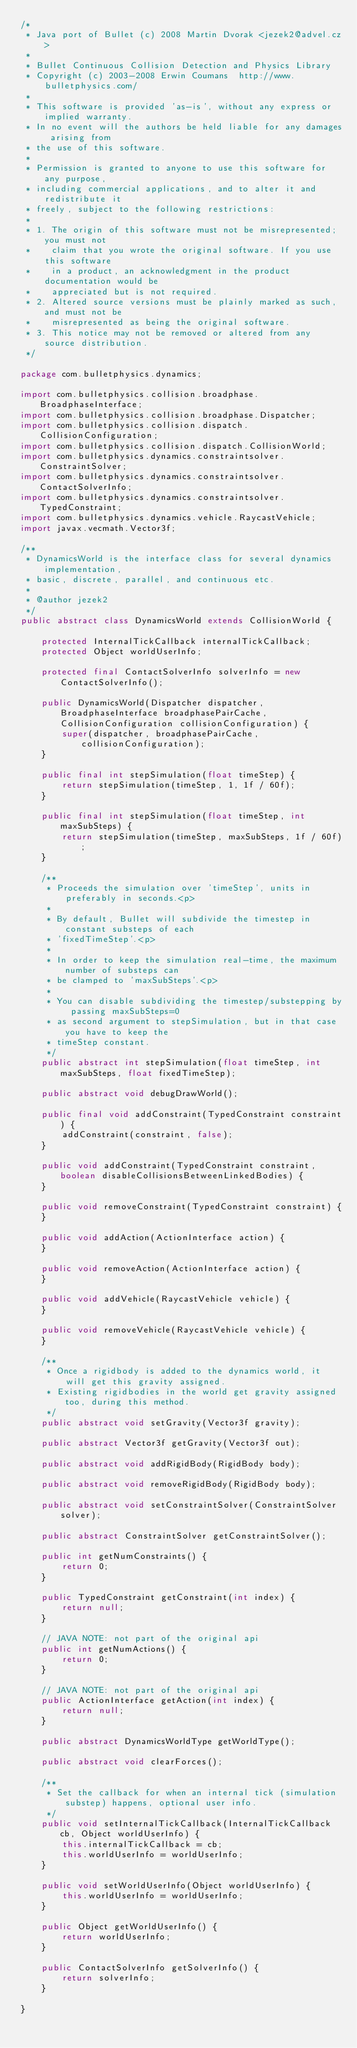Convert code to text. <code><loc_0><loc_0><loc_500><loc_500><_Java_>/*
 * Java port of Bullet (c) 2008 Martin Dvorak <jezek2@advel.cz>
 *
 * Bullet Continuous Collision Detection and Physics Library
 * Copyright (c) 2003-2008 Erwin Coumans  http://www.bulletphysics.com/
 *
 * This software is provided 'as-is', without any express or implied warranty.
 * In no event will the authors be held liable for any damages arising from
 * the use of this software.
 * 
 * Permission is granted to anyone to use this software for any purpose, 
 * including commercial applications, and to alter it and redistribute it
 * freely, subject to the following restrictions:
 * 
 * 1. The origin of this software must not be misrepresented; you must not
 *    claim that you wrote the original software. If you use this software
 *    in a product, an acknowledgment in the product documentation would be
 *    appreciated but is not required.
 * 2. Altered source versions must be plainly marked as such, and must not be
 *    misrepresented as being the original software.
 * 3. This notice may not be removed or altered from any source distribution.
 */

package com.bulletphysics.dynamics;

import com.bulletphysics.collision.broadphase.BroadphaseInterface;
import com.bulletphysics.collision.broadphase.Dispatcher;
import com.bulletphysics.collision.dispatch.CollisionConfiguration;
import com.bulletphysics.collision.dispatch.CollisionWorld;
import com.bulletphysics.dynamics.constraintsolver.ConstraintSolver;
import com.bulletphysics.dynamics.constraintsolver.ContactSolverInfo;
import com.bulletphysics.dynamics.constraintsolver.TypedConstraint;
import com.bulletphysics.dynamics.vehicle.RaycastVehicle;
import javax.vecmath.Vector3f;

/**
 * DynamicsWorld is the interface class for several dynamics implementation,
 * basic, discrete, parallel, and continuous etc.
 * 
 * @author jezek2
 */
public abstract class DynamicsWorld extends CollisionWorld {

	protected InternalTickCallback internalTickCallback;
	protected Object worldUserInfo;
	
	protected final ContactSolverInfo solverInfo = new ContactSolverInfo();
	
	public DynamicsWorld(Dispatcher dispatcher, BroadphaseInterface broadphasePairCache, CollisionConfiguration collisionConfiguration) {
		super(dispatcher, broadphasePairCache, collisionConfiguration);
	}

	public final int stepSimulation(float timeStep) {
		return stepSimulation(timeStep, 1, 1f / 60f);
	}

	public final int stepSimulation(float timeStep, int maxSubSteps) {
		return stepSimulation(timeStep, maxSubSteps, 1f / 60f);
	}

	/**
	 * Proceeds the simulation over 'timeStep', units in preferably in seconds.<p>
	 *
	 * By default, Bullet will subdivide the timestep in constant substeps of each
	 * 'fixedTimeStep'.<p>
	 *
	 * In order to keep the simulation real-time, the maximum number of substeps can
	 * be clamped to 'maxSubSteps'.<p>
	 * 
	 * You can disable subdividing the timestep/substepping by passing maxSubSteps=0
	 * as second argument to stepSimulation, but in that case you have to keep the
	 * timeStep constant.
	 */
	public abstract int stepSimulation(float timeStep, int maxSubSteps, float fixedTimeStep);

	public abstract void debugDrawWorld();

	public final void addConstraint(TypedConstraint constraint) {
		addConstraint(constraint, false);
	}
	
	public void addConstraint(TypedConstraint constraint, boolean disableCollisionsBetweenLinkedBodies) {
	}

	public void removeConstraint(TypedConstraint constraint) {
	}

	public void addAction(ActionInterface action) {
	}

	public void removeAction(ActionInterface action) {
	}

	public void addVehicle(RaycastVehicle vehicle) {
	}

	public void removeVehicle(RaycastVehicle vehicle) {
	}

	/**
	 * Once a rigidbody is added to the dynamics world, it will get this gravity assigned.
	 * Existing rigidbodies in the world get gravity assigned too, during this method.
	 */
	public abstract void setGravity(Vector3f gravity);
	
	public abstract Vector3f getGravity(Vector3f out);

	public abstract void addRigidBody(RigidBody body);

	public abstract void removeRigidBody(RigidBody body);

	public abstract void setConstraintSolver(ConstraintSolver solver);

	public abstract ConstraintSolver getConstraintSolver();

	public int getNumConstraints() {
		return 0;
	}

	public TypedConstraint getConstraint(int index) {
		return null;
	}

	// JAVA NOTE: not part of the original api
	public int getNumActions() {
		return 0;
	}

	// JAVA NOTE: not part of the original api
	public ActionInterface getAction(int index) {
		return null;
	}

	public abstract DynamicsWorldType getWorldType();

	public abstract void clearForces();
	
	/**
	 * Set the callback for when an internal tick (simulation substep) happens, optional user info.
	 */
	public void setInternalTickCallback(InternalTickCallback cb, Object worldUserInfo) {
		this.internalTickCallback = cb;
		this.worldUserInfo = worldUserInfo;
	}

	public void setWorldUserInfo(Object worldUserInfo) {
		this.worldUserInfo = worldUserInfo;
	}

	public Object getWorldUserInfo() {
		return worldUserInfo;
	}

	public ContactSolverInfo getSolverInfo() {
		return solverInfo;
	}
	
}
</code> 